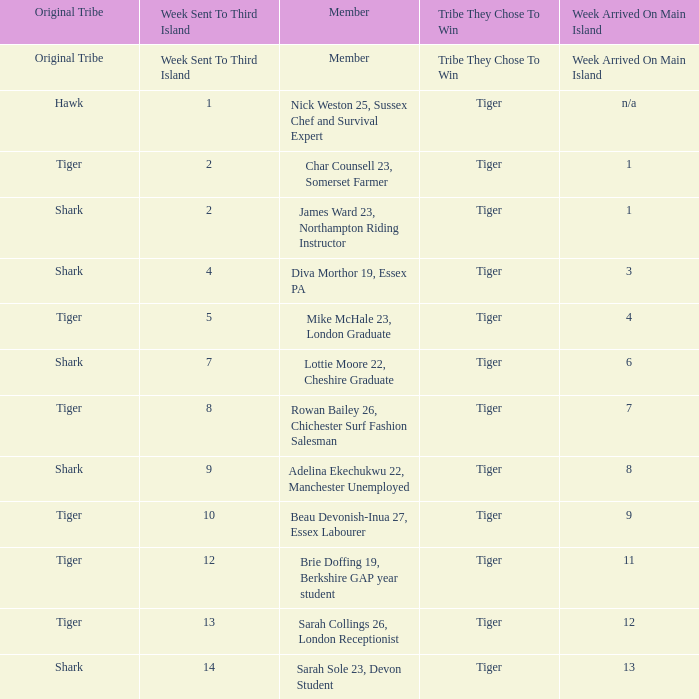What week was the member who arrived on the main island in week 6 sent to the third island? 7.0. 